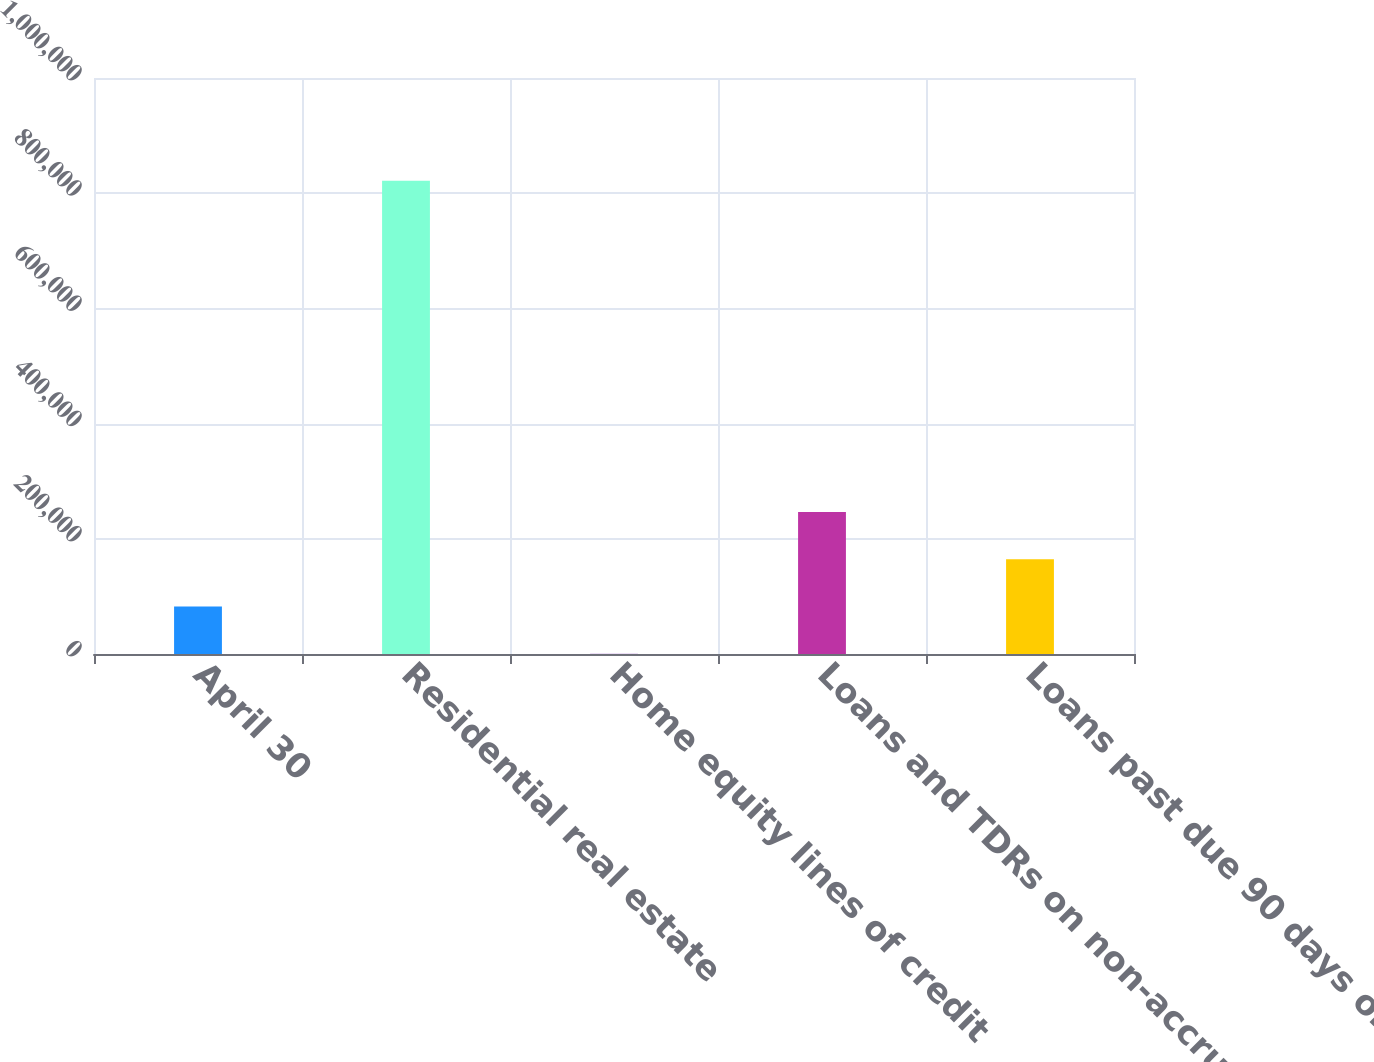<chart> <loc_0><loc_0><loc_500><loc_500><bar_chart><fcel>April 30<fcel>Residential real estate<fcel>Home equity lines of credit<fcel>Loans and TDRs on non-accrual<fcel>Loans past due 90 days or more<nl><fcel>82386.9<fcel>821583<fcel>254<fcel>246653<fcel>164520<nl></chart> 